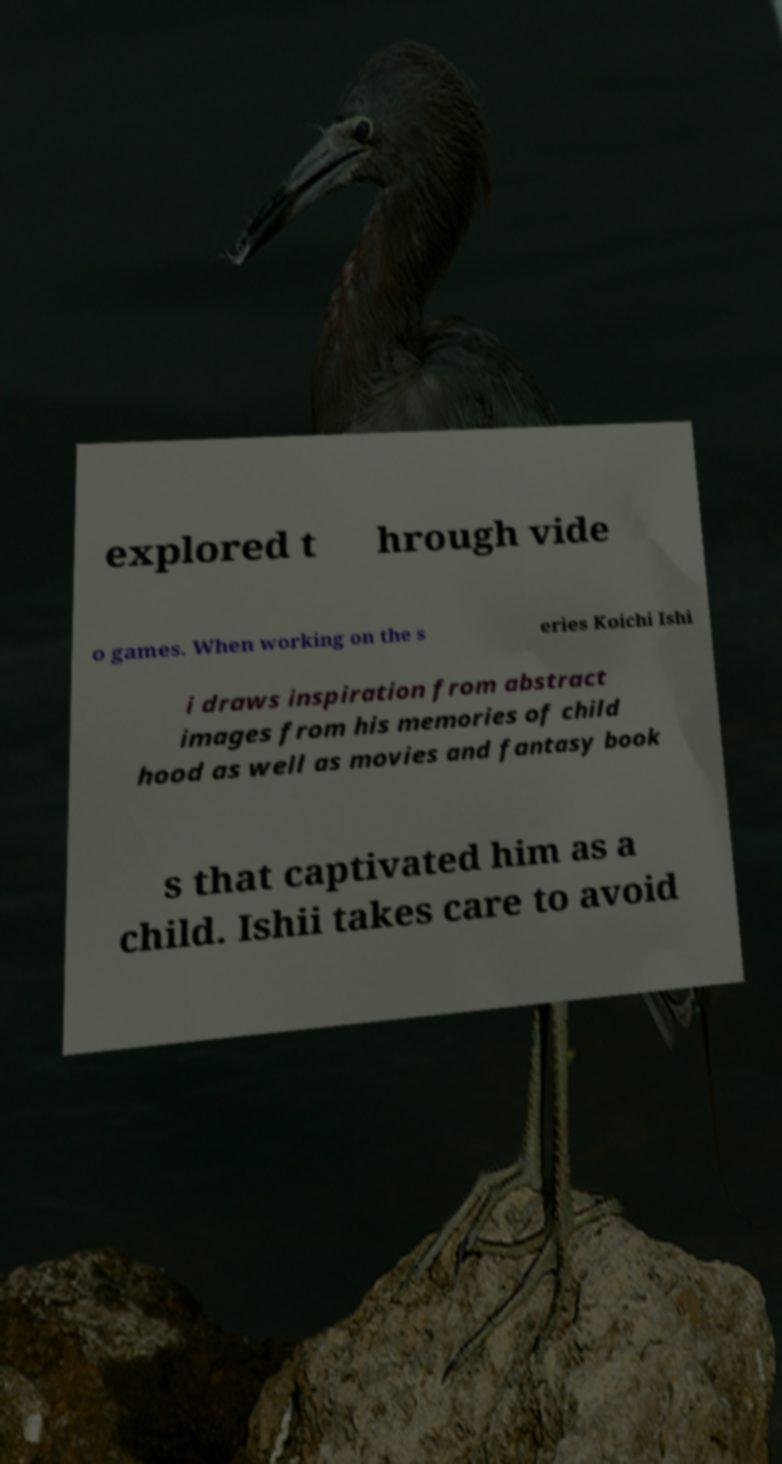Can you read and provide the text displayed in the image?This photo seems to have some interesting text. Can you extract and type it out for me? explored t hrough vide o games. When working on the s eries Koichi Ishi i draws inspiration from abstract images from his memories of child hood as well as movies and fantasy book s that captivated him as a child. Ishii takes care to avoid 